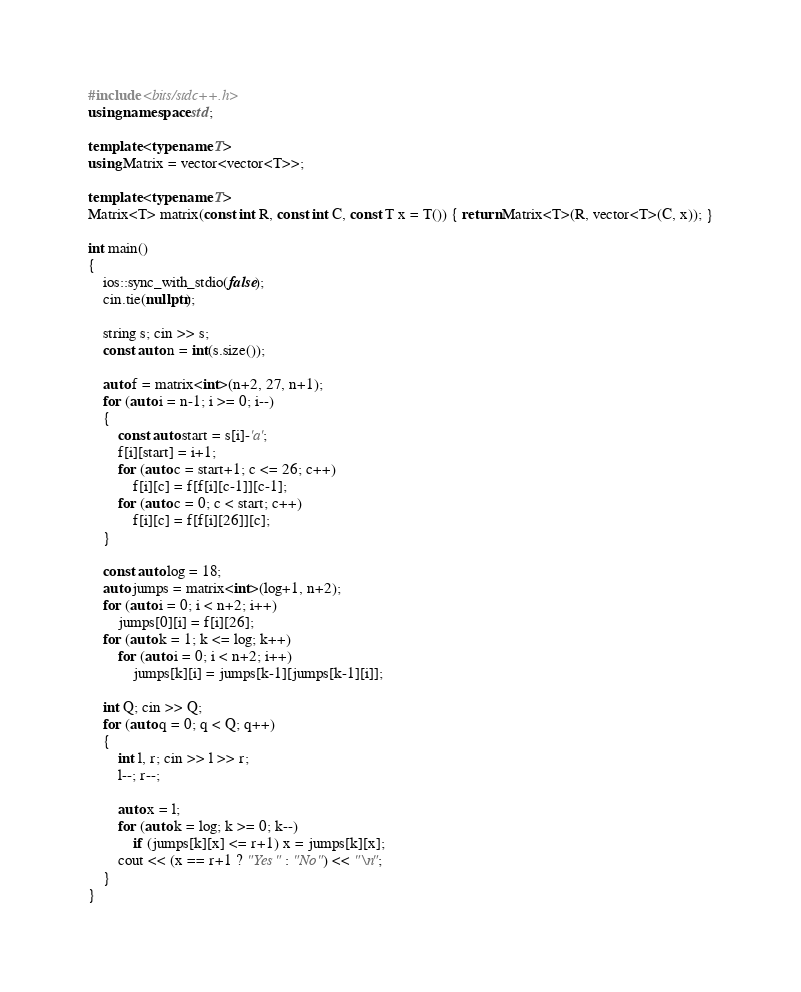<code> <loc_0><loc_0><loc_500><loc_500><_C++_>#include <bits/stdc++.h>
using namespace std;

template <typename T>
using Matrix = vector<vector<T>>;

template <typename T>
Matrix<T> matrix(const int R, const int C, const T x = T()) { return Matrix<T>(R, vector<T>(C, x)); }

int main()
{
    ios::sync_with_stdio(false);
    cin.tie(nullptr);

    string s; cin >> s;
    const auto n = int(s.size());

    auto f = matrix<int>(n+2, 27, n+1);
    for (auto i = n-1; i >= 0; i--)
    {
        const auto start = s[i]-'a';
        f[i][start] = i+1;
        for (auto c = start+1; c <= 26; c++)
            f[i][c] = f[f[i][c-1]][c-1];
        for (auto c = 0; c < start; c++)
            f[i][c] = f[f[i][26]][c];
    }

    const auto log = 18;
    auto jumps = matrix<int>(log+1, n+2);
    for (auto i = 0; i < n+2; i++)
        jumps[0][i] = f[i][26];
    for (auto k = 1; k <= log; k++)
        for (auto i = 0; i < n+2; i++)
            jumps[k][i] = jumps[k-1][jumps[k-1][i]];

    int Q; cin >> Q;
    for (auto q = 0; q < Q; q++)
    {
        int l, r; cin >> l >> r;
        l--; r--;

        auto x = l;
        for (auto k = log; k >= 0; k--)
            if (jumps[k][x] <= r+1) x = jumps[k][x];
        cout << (x == r+1 ? "Yes" : "No") << "\n";
    }
}
</code> 